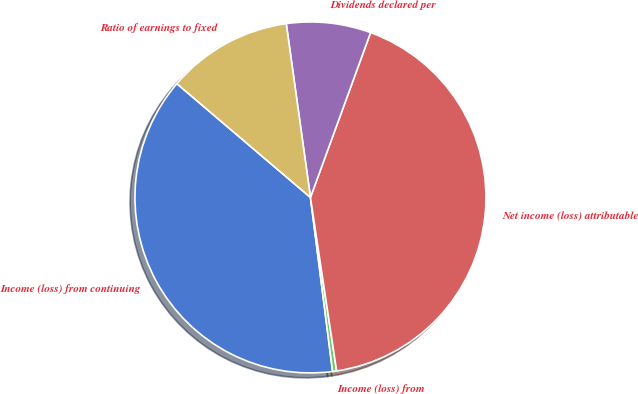Convert chart to OTSL. <chart><loc_0><loc_0><loc_500><loc_500><pie_chart><fcel>Income (loss) from continuing<fcel>Income (loss) from<fcel>Net income (loss) attributable<fcel>Dividends declared per<fcel>Ratio of earnings to fixed<nl><fcel>38.24%<fcel>0.37%<fcel>42.05%<fcel>7.77%<fcel>11.57%<nl></chart> 